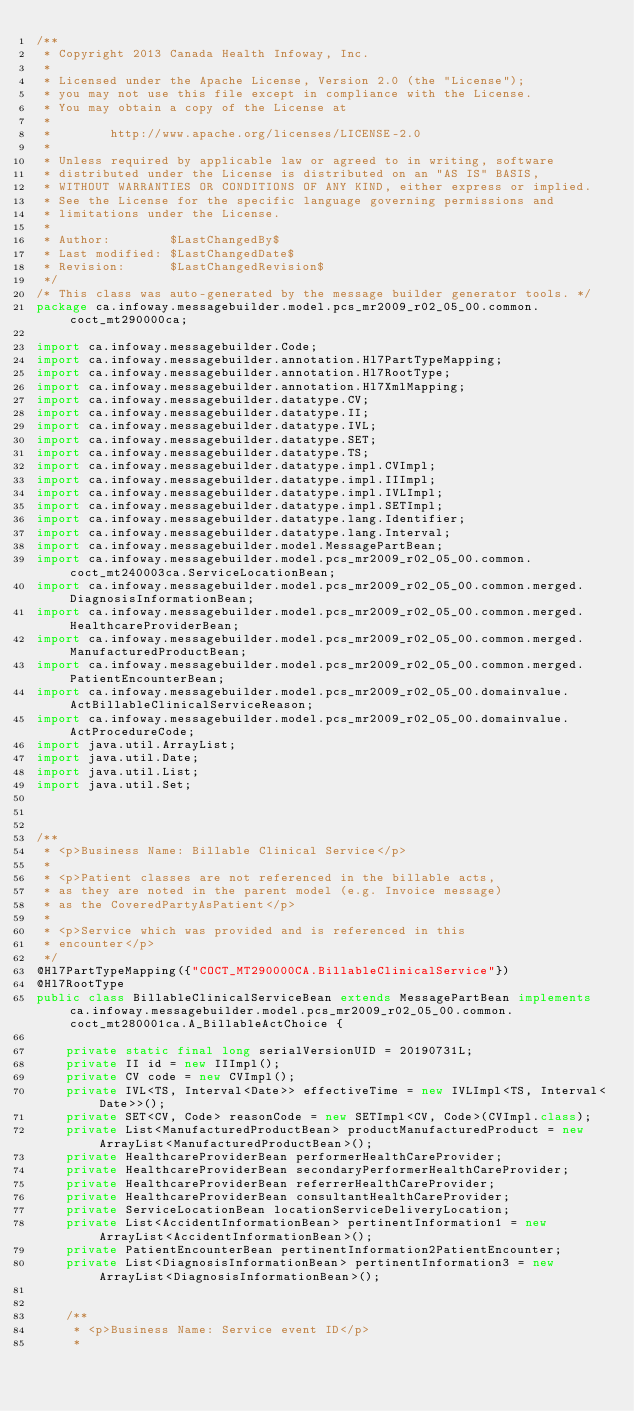<code> <loc_0><loc_0><loc_500><loc_500><_Java_>/**
 * Copyright 2013 Canada Health Infoway, Inc.
 *
 * Licensed under the Apache License, Version 2.0 (the "License");
 * you may not use this file except in compliance with the License.
 * You may obtain a copy of the License at
 *
 *        http://www.apache.org/licenses/LICENSE-2.0
 *
 * Unless required by applicable law or agreed to in writing, software
 * distributed under the License is distributed on an "AS IS" BASIS,
 * WITHOUT WARRANTIES OR CONDITIONS OF ANY KIND, either express or implied.
 * See the License for the specific language governing permissions and
 * limitations under the License.
 *
 * Author:        $LastChangedBy$
 * Last modified: $LastChangedDate$
 * Revision:      $LastChangedRevision$
 */
/* This class was auto-generated by the message builder generator tools. */
package ca.infoway.messagebuilder.model.pcs_mr2009_r02_05_00.common.coct_mt290000ca;

import ca.infoway.messagebuilder.Code;
import ca.infoway.messagebuilder.annotation.Hl7PartTypeMapping;
import ca.infoway.messagebuilder.annotation.Hl7RootType;
import ca.infoway.messagebuilder.annotation.Hl7XmlMapping;
import ca.infoway.messagebuilder.datatype.CV;
import ca.infoway.messagebuilder.datatype.II;
import ca.infoway.messagebuilder.datatype.IVL;
import ca.infoway.messagebuilder.datatype.SET;
import ca.infoway.messagebuilder.datatype.TS;
import ca.infoway.messagebuilder.datatype.impl.CVImpl;
import ca.infoway.messagebuilder.datatype.impl.IIImpl;
import ca.infoway.messagebuilder.datatype.impl.IVLImpl;
import ca.infoway.messagebuilder.datatype.impl.SETImpl;
import ca.infoway.messagebuilder.datatype.lang.Identifier;
import ca.infoway.messagebuilder.datatype.lang.Interval;
import ca.infoway.messagebuilder.model.MessagePartBean;
import ca.infoway.messagebuilder.model.pcs_mr2009_r02_05_00.common.coct_mt240003ca.ServiceLocationBean;
import ca.infoway.messagebuilder.model.pcs_mr2009_r02_05_00.common.merged.DiagnosisInformationBean;
import ca.infoway.messagebuilder.model.pcs_mr2009_r02_05_00.common.merged.HealthcareProviderBean;
import ca.infoway.messagebuilder.model.pcs_mr2009_r02_05_00.common.merged.ManufacturedProductBean;
import ca.infoway.messagebuilder.model.pcs_mr2009_r02_05_00.common.merged.PatientEncounterBean;
import ca.infoway.messagebuilder.model.pcs_mr2009_r02_05_00.domainvalue.ActBillableClinicalServiceReason;
import ca.infoway.messagebuilder.model.pcs_mr2009_r02_05_00.domainvalue.ActProcedureCode;
import java.util.ArrayList;
import java.util.Date;
import java.util.List;
import java.util.Set;



/**
 * <p>Business Name: Billable Clinical Service</p>
 * 
 * <p>Patient classes are not referenced in the billable acts, 
 * as they are noted in the parent model (e.g. Invoice message) 
 * as the CoveredPartyAsPatient</p>
 * 
 * <p>Service which was provided and is referenced in this 
 * encounter</p>
 */
@Hl7PartTypeMapping({"COCT_MT290000CA.BillableClinicalService"})
@Hl7RootType
public class BillableClinicalServiceBean extends MessagePartBean implements ca.infoway.messagebuilder.model.pcs_mr2009_r02_05_00.common.coct_mt280001ca.A_BillableActChoice {

    private static final long serialVersionUID = 20190731L;
    private II id = new IIImpl();
    private CV code = new CVImpl();
    private IVL<TS, Interval<Date>> effectiveTime = new IVLImpl<TS, Interval<Date>>();
    private SET<CV, Code> reasonCode = new SETImpl<CV, Code>(CVImpl.class);
    private List<ManufacturedProductBean> productManufacturedProduct = new ArrayList<ManufacturedProductBean>();
    private HealthcareProviderBean performerHealthCareProvider;
    private HealthcareProviderBean secondaryPerformerHealthCareProvider;
    private HealthcareProviderBean referrerHealthCareProvider;
    private HealthcareProviderBean consultantHealthCareProvider;
    private ServiceLocationBean locationServiceDeliveryLocation;
    private List<AccidentInformationBean> pertinentInformation1 = new ArrayList<AccidentInformationBean>();
    private PatientEncounterBean pertinentInformation2PatientEncounter;
    private List<DiagnosisInformationBean> pertinentInformation3 = new ArrayList<DiagnosisInformationBean>();


    /**
     * <p>Business Name: Service event ID</p>
     * </code> 